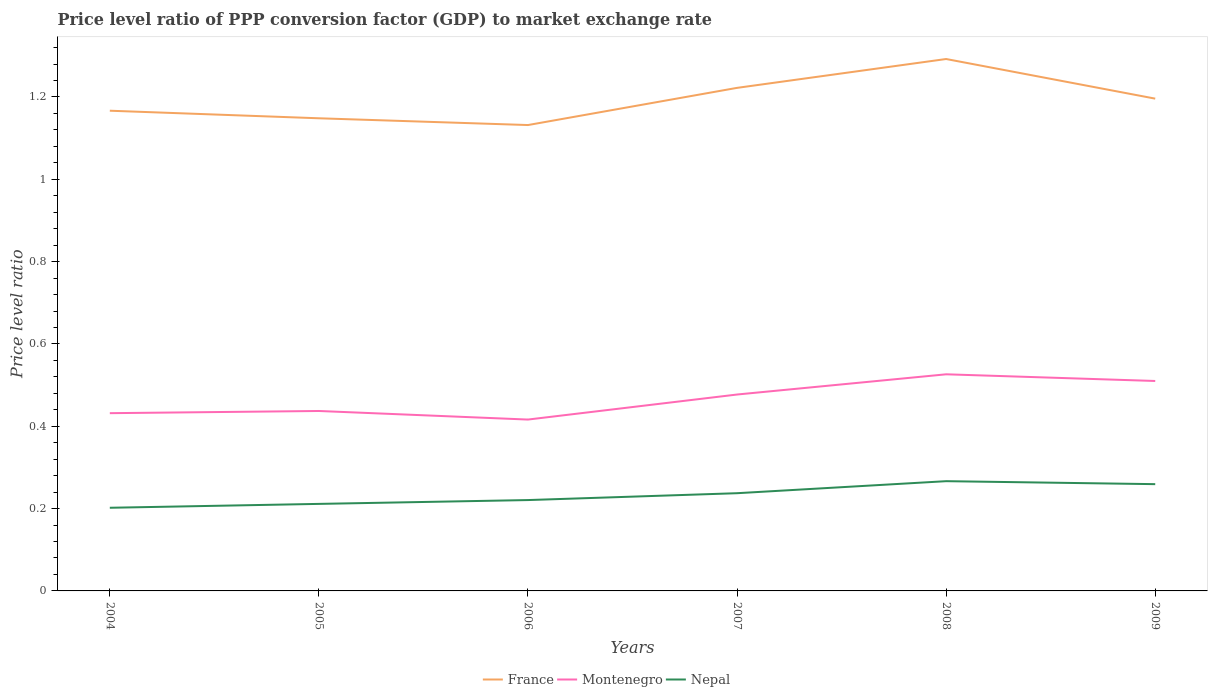Does the line corresponding to Montenegro intersect with the line corresponding to Nepal?
Offer a terse response. No. Is the number of lines equal to the number of legend labels?
Make the answer very short. Yes. Across all years, what is the maximum price level ratio in Nepal?
Your answer should be compact. 0.2. In which year was the price level ratio in France maximum?
Provide a short and direct response. 2006. What is the total price level ratio in France in the graph?
Make the answer very short. -0.07. What is the difference between the highest and the second highest price level ratio in France?
Your answer should be very brief. 0.16. Is the price level ratio in Nepal strictly greater than the price level ratio in France over the years?
Ensure brevity in your answer.  Yes. What is the difference between two consecutive major ticks on the Y-axis?
Your answer should be very brief. 0.2. Are the values on the major ticks of Y-axis written in scientific E-notation?
Your answer should be compact. No. Where does the legend appear in the graph?
Offer a very short reply. Bottom center. How many legend labels are there?
Make the answer very short. 3. How are the legend labels stacked?
Your answer should be very brief. Horizontal. What is the title of the graph?
Offer a terse response. Price level ratio of PPP conversion factor (GDP) to market exchange rate. Does "Turks and Caicos Islands" appear as one of the legend labels in the graph?
Keep it short and to the point. No. What is the label or title of the Y-axis?
Your response must be concise. Price level ratio. What is the Price level ratio of France in 2004?
Keep it short and to the point. 1.17. What is the Price level ratio in Montenegro in 2004?
Your response must be concise. 0.43. What is the Price level ratio in Nepal in 2004?
Your answer should be very brief. 0.2. What is the Price level ratio of France in 2005?
Give a very brief answer. 1.15. What is the Price level ratio of Montenegro in 2005?
Your response must be concise. 0.44. What is the Price level ratio in Nepal in 2005?
Provide a succinct answer. 0.21. What is the Price level ratio in France in 2006?
Provide a succinct answer. 1.13. What is the Price level ratio of Montenegro in 2006?
Provide a succinct answer. 0.42. What is the Price level ratio in Nepal in 2006?
Offer a very short reply. 0.22. What is the Price level ratio in France in 2007?
Offer a very short reply. 1.22. What is the Price level ratio in Montenegro in 2007?
Make the answer very short. 0.48. What is the Price level ratio of Nepal in 2007?
Provide a short and direct response. 0.24. What is the Price level ratio in France in 2008?
Offer a terse response. 1.29. What is the Price level ratio of Montenegro in 2008?
Your answer should be compact. 0.53. What is the Price level ratio in Nepal in 2008?
Make the answer very short. 0.27. What is the Price level ratio in France in 2009?
Provide a short and direct response. 1.2. What is the Price level ratio in Montenegro in 2009?
Provide a short and direct response. 0.51. What is the Price level ratio in Nepal in 2009?
Ensure brevity in your answer.  0.26. Across all years, what is the maximum Price level ratio of France?
Offer a terse response. 1.29. Across all years, what is the maximum Price level ratio of Montenegro?
Provide a succinct answer. 0.53. Across all years, what is the maximum Price level ratio in Nepal?
Provide a succinct answer. 0.27. Across all years, what is the minimum Price level ratio of France?
Give a very brief answer. 1.13. Across all years, what is the minimum Price level ratio of Montenegro?
Provide a short and direct response. 0.42. Across all years, what is the minimum Price level ratio in Nepal?
Offer a very short reply. 0.2. What is the total Price level ratio of France in the graph?
Provide a short and direct response. 7.16. What is the total Price level ratio in Montenegro in the graph?
Ensure brevity in your answer.  2.8. What is the total Price level ratio in Nepal in the graph?
Keep it short and to the point. 1.4. What is the difference between the Price level ratio of France in 2004 and that in 2005?
Offer a terse response. 0.02. What is the difference between the Price level ratio of Montenegro in 2004 and that in 2005?
Keep it short and to the point. -0.01. What is the difference between the Price level ratio in Nepal in 2004 and that in 2005?
Provide a succinct answer. -0.01. What is the difference between the Price level ratio in France in 2004 and that in 2006?
Give a very brief answer. 0.03. What is the difference between the Price level ratio of Montenegro in 2004 and that in 2006?
Offer a very short reply. 0.02. What is the difference between the Price level ratio of Nepal in 2004 and that in 2006?
Offer a very short reply. -0.02. What is the difference between the Price level ratio of France in 2004 and that in 2007?
Provide a short and direct response. -0.06. What is the difference between the Price level ratio in Montenegro in 2004 and that in 2007?
Provide a short and direct response. -0.05. What is the difference between the Price level ratio in Nepal in 2004 and that in 2007?
Keep it short and to the point. -0.04. What is the difference between the Price level ratio in France in 2004 and that in 2008?
Keep it short and to the point. -0.13. What is the difference between the Price level ratio in Montenegro in 2004 and that in 2008?
Your answer should be compact. -0.09. What is the difference between the Price level ratio of Nepal in 2004 and that in 2008?
Offer a terse response. -0.06. What is the difference between the Price level ratio in France in 2004 and that in 2009?
Your response must be concise. -0.03. What is the difference between the Price level ratio of Montenegro in 2004 and that in 2009?
Give a very brief answer. -0.08. What is the difference between the Price level ratio of Nepal in 2004 and that in 2009?
Offer a terse response. -0.06. What is the difference between the Price level ratio in France in 2005 and that in 2006?
Make the answer very short. 0.02. What is the difference between the Price level ratio of Montenegro in 2005 and that in 2006?
Give a very brief answer. 0.02. What is the difference between the Price level ratio of Nepal in 2005 and that in 2006?
Offer a terse response. -0.01. What is the difference between the Price level ratio in France in 2005 and that in 2007?
Provide a short and direct response. -0.07. What is the difference between the Price level ratio of Montenegro in 2005 and that in 2007?
Give a very brief answer. -0.04. What is the difference between the Price level ratio in Nepal in 2005 and that in 2007?
Your answer should be compact. -0.03. What is the difference between the Price level ratio in France in 2005 and that in 2008?
Make the answer very short. -0.14. What is the difference between the Price level ratio in Montenegro in 2005 and that in 2008?
Make the answer very short. -0.09. What is the difference between the Price level ratio of Nepal in 2005 and that in 2008?
Your answer should be compact. -0.06. What is the difference between the Price level ratio in France in 2005 and that in 2009?
Provide a succinct answer. -0.05. What is the difference between the Price level ratio in Montenegro in 2005 and that in 2009?
Provide a short and direct response. -0.07. What is the difference between the Price level ratio in Nepal in 2005 and that in 2009?
Provide a short and direct response. -0.05. What is the difference between the Price level ratio of France in 2006 and that in 2007?
Your answer should be very brief. -0.09. What is the difference between the Price level ratio in Montenegro in 2006 and that in 2007?
Ensure brevity in your answer.  -0.06. What is the difference between the Price level ratio in Nepal in 2006 and that in 2007?
Provide a short and direct response. -0.02. What is the difference between the Price level ratio in France in 2006 and that in 2008?
Provide a succinct answer. -0.16. What is the difference between the Price level ratio in Montenegro in 2006 and that in 2008?
Provide a succinct answer. -0.11. What is the difference between the Price level ratio in Nepal in 2006 and that in 2008?
Give a very brief answer. -0.05. What is the difference between the Price level ratio in France in 2006 and that in 2009?
Give a very brief answer. -0.06. What is the difference between the Price level ratio of Montenegro in 2006 and that in 2009?
Keep it short and to the point. -0.09. What is the difference between the Price level ratio of Nepal in 2006 and that in 2009?
Your answer should be very brief. -0.04. What is the difference between the Price level ratio of France in 2007 and that in 2008?
Your response must be concise. -0.07. What is the difference between the Price level ratio in Montenegro in 2007 and that in 2008?
Ensure brevity in your answer.  -0.05. What is the difference between the Price level ratio in Nepal in 2007 and that in 2008?
Offer a terse response. -0.03. What is the difference between the Price level ratio of France in 2007 and that in 2009?
Provide a short and direct response. 0.03. What is the difference between the Price level ratio of Montenegro in 2007 and that in 2009?
Offer a terse response. -0.03. What is the difference between the Price level ratio in Nepal in 2007 and that in 2009?
Your answer should be very brief. -0.02. What is the difference between the Price level ratio in France in 2008 and that in 2009?
Keep it short and to the point. 0.1. What is the difference between the Price level ratio in Montenegro in 2008 and that in 2009?
Ensure brevity in your answer.  0.02. What is the difference between the Price level ratio in Nepal in 2008 and that in 2009?
Ensure brevity in your answer.  0.01. What is the difference between the Price level ratio of France in 2004 and the Price level ratio of Montenegro in 2005?
Offer a very short reply. 0.73. What is the difference between the Price level ratio of France in 2004 and the Price level ratio of Nepal in 2005?
Your answer should be very brief. 0.96. What is the difference between the Price level ratio in Montenegro in 2004 and the Price level ratio in Nepal in 2005?
Provide a short and direct response. 0.22. What is the difference between the Price level ratio in France in 2004 and the Price level ratio in Montenegro in 2006?
Offer a very short reply. 0.75. What is the difference between the Price level ratio of France in 2004 and the Price level ratio of Nepal in 2006?
Give a very brief answer. 0.95. What is the difference between the Price level ratio in Montenegro in 2004 and the Price level ratio in Nepal in 2006?
Your answer should be very brief. 0.21. What is the difference between the Price level ratio in France in 2004 and the Price level ratio in Montenegro in 2007?
Your response must be concise. 0.69. What is the difference between the Price level ratio of France in 2004 and the Price level ratio of Nepal in 2007?
Offer a terse response. 0.93. What is the difference between the Price level ratio of Montenegro in 2004 and the Price level ratio of Nepal in 2007?
Your answer should be compact. 0.19. What is the difference between the Price level ratio in France in 2004 and the Price level ratio in Montenegro in 2008?
Provide a short and direct response. 0.64. What is the difference between the Price level ratio of France in 2004 and the Price level ratio of Nepal in 2008?
Your answer should be compact. 0.9. What is the difference between the Price level ratio of Montenegro in 2004 and the Price level ratio of Nepal in 2008?
Your answer should be compact. 0.17. What is the difference between the Price level ratio of France in 2004 and the Price level ratio of Montenegro in 2009?
Give a very brief answer. 0.66. What is the difference between the Price level ratio of France in 2004 and the Price level ratio of Nepal in 2009?
Give a very brief answer. 0.91. What is the difference between the Price level ratio in Montenegro in 2004 and the Price level ratio in Nepal in 2009?
Your response must be concise. 0.17. What is the difference between the Price level ratio in France in 2005 and the Price level ratio in Montenegro in 2006?
Your response must be concise. 0.73. What is the difference between the Price level ratio in France in 2005 and the Price level ratio in Nepal in 2006?
Offer a very short reply. 0.93. What is the difference between the Price level ratio in Montenegro in 2005 and the Price level ratio in Nepal in 2006?
Provide a succinct answer. 0.22. What is the difference between the Price level ratio of France in 2005 and the Price level ratio of Montenegro in 2007?
Your answer should be very brief. 0.67. What is the difference between the Price level ratio in France in 2005 and the Price level ratio in Nepal in 2007?
Ensure brevity in your answer.  0.91. What is the difference between the Price level ratio in Montenegro in 2005 and the Price level ratio in Nepal in 2007?
Make the answer very short. 0.2. What is the difference between the Price level ratio in France in 2005 and the Price level ratio in Montenegro in 2008?
Your response must be concise. 0.62. What is the difference between the Price level ratio in France in 2005 and the Price level ratio in Nepal in 2008?
Offer a terse response. 0.88. What is the difference between the Price level ratio of Montenegro in 2005 and the Price level ratio of Nepal in 2008?
Your response must be concise. 0.17. What is the difference between the Price level ratio in France in 2005 and the Price level ratio in Montenegro in 2009?
Offer a very short reply. 0.64. What is the difference between the Price level ratio of France in 2005 and the Price level ratio of Nepal in 2009?
Provide a short and direct response. 0.89. What is the difference between the Price level ratio in Montenegro in 2005 and the Price level ratio in Nepal in 2009?
Offer a terse response. 0.18. What is the difference between the Price level ratio in France in 2006 and the Price level ratio in Montenegro in 2007?
Provide a succinct answer. 0.65. What is the difference between the Price level ratio of France in 2006 and the Price level ratio of Nepal in 2007?
Give a very brief answer. 0.89. What is the difference between the Price level ratio in Montenegro in 2006 and the Price level ratio in Nepal in 2007?
Keep it short and to the point. 0.18. What is the difference between the Price level ratio in France in 2006 and the Price level ratio in Montenegro in 2008?
Your answer should be compact. 0.61. What is the difference between the Price level ratio in France in 2006 and the Price level ratio in Nepal in 2008?
Provide a succinct answer. 0.87. What is the difference between the Price level ratio in Montenegro in 2006 and the Price level ratio in Nepal in 2008?
Ensure brevity in your answer.  0.15. What is the difference between the Price level ratio in France in 2006 and the Price level ratio in Montenegro in 2009?
Provide a short and direct response. 0.62. What is the difference between the Price level ratio of France in 2006 and the Price level ratio of Nepal in 2009?
Provide a short and direct response. 0.87. What is the difference between the Price level ratio in Montenegro in 2006 and the Price level ratio in Nepal in 2009?
Make the answer very short. 0.16. What is the difference between the Price level ratio of France in 2007 and the Price level ratio of Montenegro in 2008?
Provide a succinct answer. 0.7. What is the difference between the Price level ratio of France in 2007 and the Price level ratio of Nepal in 2008?
Your answer should be very brief. 0.96. What is the difference between the Price level ratio in Montenegro in 2007 and the Price level ratio in Nepal in 2008?
Provide a succinct answer. 0.21. What is the difference between the Price level ratio of France in 2007 and the Price level ratio of Montenegro in 2009?
Make the answer very short. 0.71. What is the difference between the Price level ratio of France in 2007 and the Price level ratio of Nepal in 2009?
Ensure brevity in your answer.  0.96. What is the difference between the Price level ratio in Montenegro in 2007 and the Price level ratio in Nepal in 2009?
Give a very brief answer. 0.22. What is the difference between the Price level ratio of France in 2008 and the Price level ratio of Montenegro in 2009?
Make the answer very short. 0.78. What is the difference between the Price level ratio in France in 2008 and the Price level ratio in Nepal in 2009?
Make the answer very short. 1.03. What is the difference between the Price level ratio of Montenegro in 2008 and the Price level ratio of Nepal in 2009?
Offer a terse response. 0.27. What is the average Price level ratio of France per year?
Offer a terse response. 1.19. What is the average Price level ratio of Montenegro per year?
Provide a short and direct response. 0.47. What is the average Price level ratio in Nepal per year?
Your response must be concise. 0.23. In the year 2004, what is the difference between the Price level ratio of France and Price level ratio of Montenegro?
Provide a succinct answer. 0.73. In the year 2004, what is the difference between the Price level ratio in France and Price level ratio in Nepal?
Ensure brevity in your answer.  0.96. In the year 2004, what is the difference between the Price level ratio in Montenegro and Price level ratio in Nepal?
Provide a short and direct response. 0.23. In the year 2005, what is the difference between the Price level ratio in France and Price level ratio in Montenegro?
Make the answer very short. 0.71. In the year 2005, what is the difference between the Price level ratio in France and Price level ratio in Nepal?
Provide a short and direct response. 0.94. In the year 2005, what is the difference between the Price level ratio of Montenegro and Price level ratio of Nepal?
Offer a terse response. 0.23. In the year 2006, what is the difference between the Price level ratio of France and Price level ratio of Montenegro?
Your answer should be compact. 0.72. In the year 2006, what is the difference between the Price level ratio in France and Price level ratio in Nepal?
Make the answer very short. 0.91. In the year 2006, what is the difference between the Price level ratio of Montenegro and Price level ratio of Nepal?
Offer a very short reply. 0.2. In the year 2007, what is the difference between the Price level ratio of France and Price level ratio of Montenegro?
Give a very brief answer. 0.74. In the year 2007, what is the difference between the Price level ratio in Montenegro and Price level ratio in Nepal?
Give a very brief answer. 0.24. In the year 2008, what is the difference between the Price level ratio in France and Price level ratio in Montenegro?
Offer a terse response. 0.77. In the year 2008, what is the difference between the Price level ratio in France and Price level ratio in Nepal?
Your response must be concise. 1.03. In the year 2008, what is the difference between the Price level ratio of Montenegro and Price level ratio of Nepal?
Offer a terse response. 0.26. In the year 2009, what is the difference between the Price level ratio of France and Price level ratio of Montenegro?
Provide a succinct answer. 0.69. In the year 2009, what is the difference between the Price level ratio of France and Price level ratio of Nepal?
Ensure brevity in your answer.  0.94. In the year 2009, what is the difference between the Price level ratio of Montenegro and Price level ratio of Nepal?
Give a very brief answer. 0.25. What is the ratio of the Price level ratio of France in 2004 to that in 2005?
Your answer should be very brief. 1.02. What is the ratio of the Price level ratio of Montenegro in 2004 to that in 2005?
Provide a succinct answer. 0.99. What is the ratio of the Price level ratio in Nepal in 2004 to that in 2005?
Keep it short and to the point. 0.96. What is the ratio of the Price level ratio in France in 2004 to that in 2006?
Your response must be concise. 1.03. What is the ratio of the Price level ratio in Montenegro in 2004 to that in 2006?
Keep it short and to the point. 1.04. What is the ratio of the Price level ratio of Nepal in 2004 to that in 2006?
Give a very brief answer. 0.92. What is the ratio of the Price level ratio of France in 2004 to that in 2007?
Your response must be concise. 0.95. What is the ratio of the Price level ratio of Montenegro in 2004 to that in 2007?
Offer a terse response. 0.91. What is the ratio of the Price level ratio in Nepal in 2004 to that in 2007?
Ensure brevity in your answer.  0.85. What is the ratio of the Price level ratio in France in 2004 to that in 2008?
Make the answer very short. 0.9. What is the ratio of the Price level ratio in Montenegro in 2004 to that in 2008?
Offer a terse response. 0.82. What is the ratio of the Price level ratio in Nepal in 2004 to that in 2008?
Offer a terse response. 0.76. What is the ratio of the Price level ratio of France in 2004 to that in 2009?
Offer a very short reply. 0.98. What is the ratio of the Price level ratio in Montenegro in 2004 to that in 2009?
Ensure brevity in your answer.  0.85. What is the ratio of the Price level ratio of Nepal in 2004 to that in 2009?
Your answer should be compact. 0.78. What is the ratio of the Price level ratio in France in 2005 to that in 2006?
Ensure brevity in your answer.  1.01. What is the ratio of the Price level ratio of Montenegro in 2005 to that in 2006?
Offer a very short reply. 1.05. What is the ratio of the Price level ratio of Nepal in 2005 to that in 2006?
Ensure brevity in your answer.  0.96. What is the ratio of the Price level ratio in France in 2005 to that in 2007?
Offer a very short reply. 0.94. What is the ratio of the Price level ratio of Montenegro in 2005 to that in 2007?
Make the answer very short. 0.92. What is the ratio of the Price level ratio in Nepal in 2005 to that in 2007?
Your answer should be very brief. 0.89. What is the ratio of the Price level ratio in France in 2005 to that in 2008?
Provide a succinct answer. 0.89. What is the ratio of the Price level ratio of Montenegro in 2005 to that in 2008?
Your response must be concise. 0.83. What is the ratio of the Price level ratio in Nepal in 2005 to that in 2008?
Keep it short and to the point. 0.79. What is the ratio of the Price level ratio of France in 2005 to that in 2009?
Keep it short and to the point. 0.96. What is the ratio of the Price level ratio in Montenegro in 2005 to that in 2009?
Ensure brevity in your answer.  0.86. What is the ratio of the Price level ratio of Nepal in 2005 to that in 2009?
Ensure brevity in your answer.  0.82. What is the ratio of the Price level ratio in France in 2006 to that in 2007?
Offer a very short reply. 0.93. What is the ratio of the Price level ratio in Montenegro in 2006 to that in 2007?
Offer a terse response. 0.87. What is the ratio of the Price level ratio of Nepal in 2006 to that in 2007?
Your answer should be very brief. 0.93. What is the ratio of the Price level ratio of France in 2006 to that in 2008?
Give a very brief answer. 0.88. What is the ratio of the Price level ratio of Montenegro in 2006 to that in 2008?
Give a very brief answer. 0.79. What is the ratio of the Price level ratio of Nepal in 2006 to that in 2008?
Ensure brevity in your answer.  0.83. What is the ratio of the Price level ratio of France in 2006 to that in 2009?
Provide a short and direct response. 0.95. What is the ratio of the Price level ratio of Montenegro in 2006 to that in 2009?
Provide a short and direct response. 0.82. What is the ratio of the Price level ratio of Nepal in 2006 to that in 2009?
Your answer should be compact. 0.85. What is the ratio of the Price level ratio in France in 2007 to that in 2008?
Your response must be concise. 0.95. What is the ratio of the Price level ratio of Montenegro in 2007 to that in 2008?
Offer a very short reply. 0.91. What is the ratio of the Price level ratio of Nepal in 2007 to that in 2008?
Your answer should be compact. 0.89. What is the ratio of the Price level ratio of France in 2007 to that in 2009?
Provide a short and direct response. 1.02. What is the ratio of the Price level ratio of Montenegro in 2007 to that in 2009?
Make the answer very short. 0.94. What is the ratio of the Price level ratio of Nepal in 2007 to that in 2009?
Ensure brevity in your answer.  0.92. What is the ratio of the Price level ratio of France in 2008 to that in 2009?
Provide a succinct answer. 1.08. What is the ratio of the Price level ratio of Montenegro in 2008 to that in 2009?
Your answer should be very brief. 1.03. What is the ratio of the Price level ratio of Nepal in 2008 to that in 2009?
Give a very brief answer. 1.03. What is the difference between the highest and the second highest Price level ratio in France?
Offer a terse response. 0.07. What is the difference between the highest and the second highest Price level ratio of Montenegro?
Make the answer very short. 0.02. What is the difference between the highest and the second highest Price level ratio in Nepal?
Make the answer very short. 0.01. What is the difference between the highest and the lowest Price level ratio of France?
Provide a succinct answer. 0.16. What is the difference between the highest and the lowest Price level ratio of Montenegro?
Your answer should be very brief. 0.11. What is the difference between the highest and the lowest Price level ratio of Nepal?
Offer a very short reply. 0.06. 